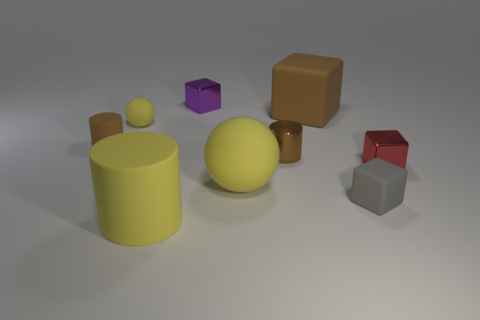There is a large rubber ball; what number of rubber things are on the left side of it?
Keep it short and to the point. 3. There is a small shiny cube that is right of the metallic block that is behind the brown thing on the left side of the purple cube; what is its color?
Provide a short and direct response. Red. There is a tiny rubber cube on the right side of the large matte cube; is it the same color as the tiny cylinder that is left of the yellow matte cylinder?
Ensure brevity in your answer.  No. The brown object left of the rubber sphere to the right of the purple metal thing is what shape?
Give a very brief answer. Cylinder. Are there any red things of the same size as the gray matte cube?
Keep it short and to the point. Yes. What number of red objects are the same shape as the small gray thing?
Your answer should be very brief. 1. Is the number of brown shiny objects that are to the right of the red metal object the same as the number of big matte blocks that are on the right side of the large cube?
Give a very brief answer. Yes. Are any matte spheres visible?
Offer a very short reply. Yes. What size is the sphere that is on the left side of the purple block that is behind the large yellow matte thing that is behind the big yellow cylinder?
Keep it short and to the point. Small. There is a red object that is the same size as the gray cube; what is its shape?
Offer a terse response. Cube. 